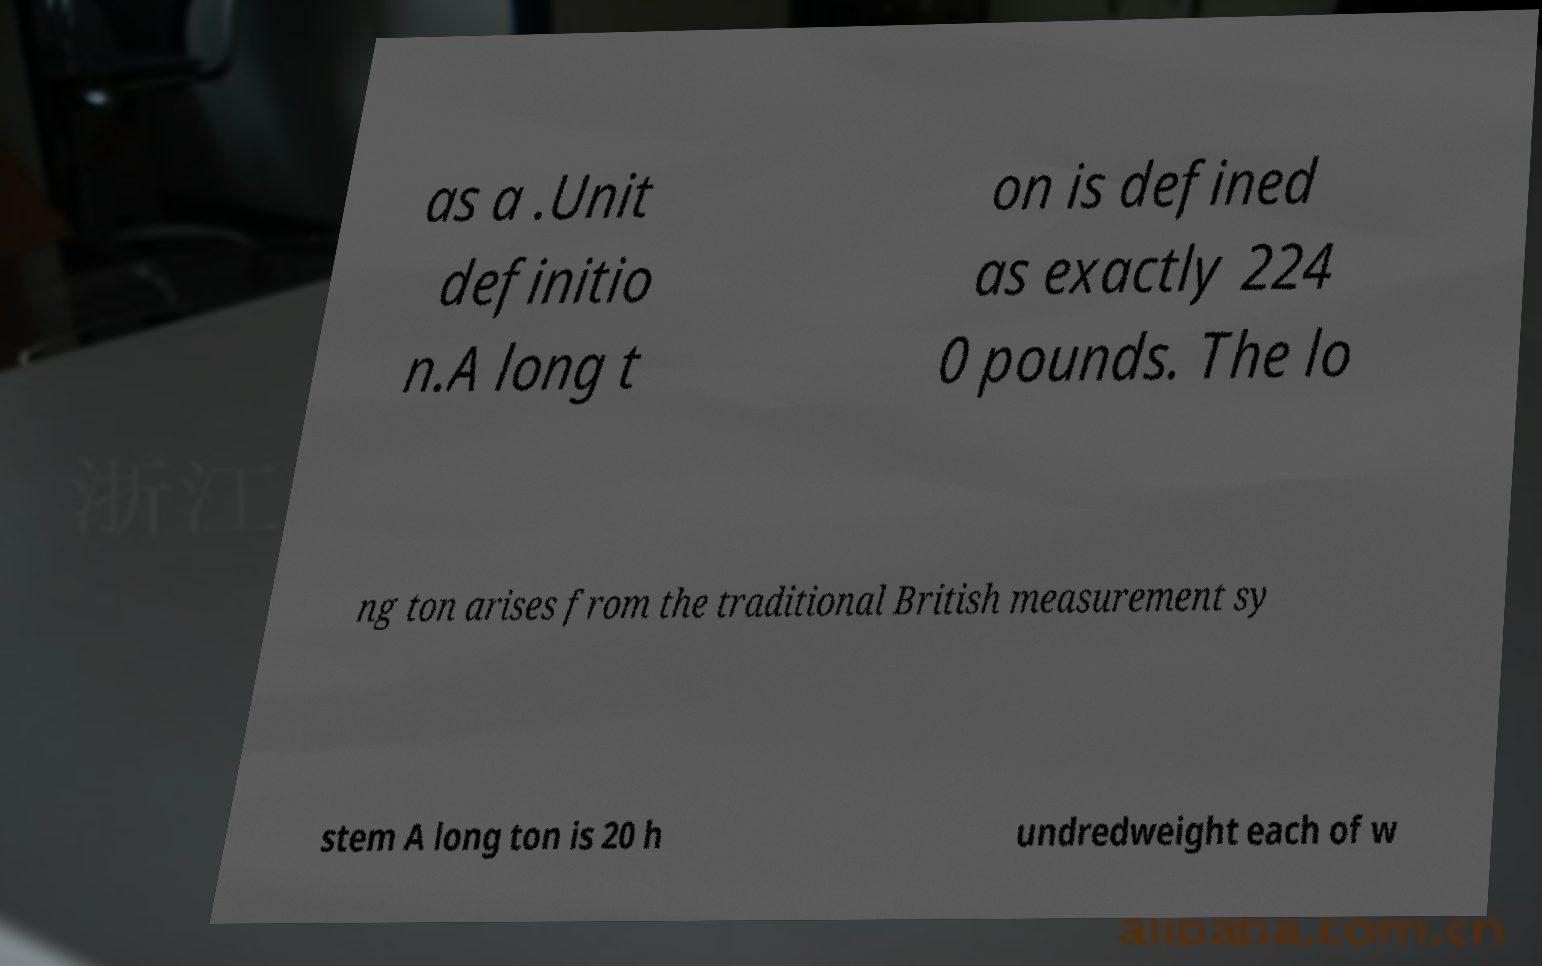Please identify and transcribe the text found in this image. as a .Unit definitio n.A long t on is defined as exactly 224 0 pounds. The lo ng ton arises from the traditional British measurement sy stem A long ton is 20 h undredweight each of w 